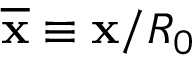<formula> <loc_0><loc_0><loc_500><loc_500>\overline { x } \equiv x / R _ { 0 }</formula> 